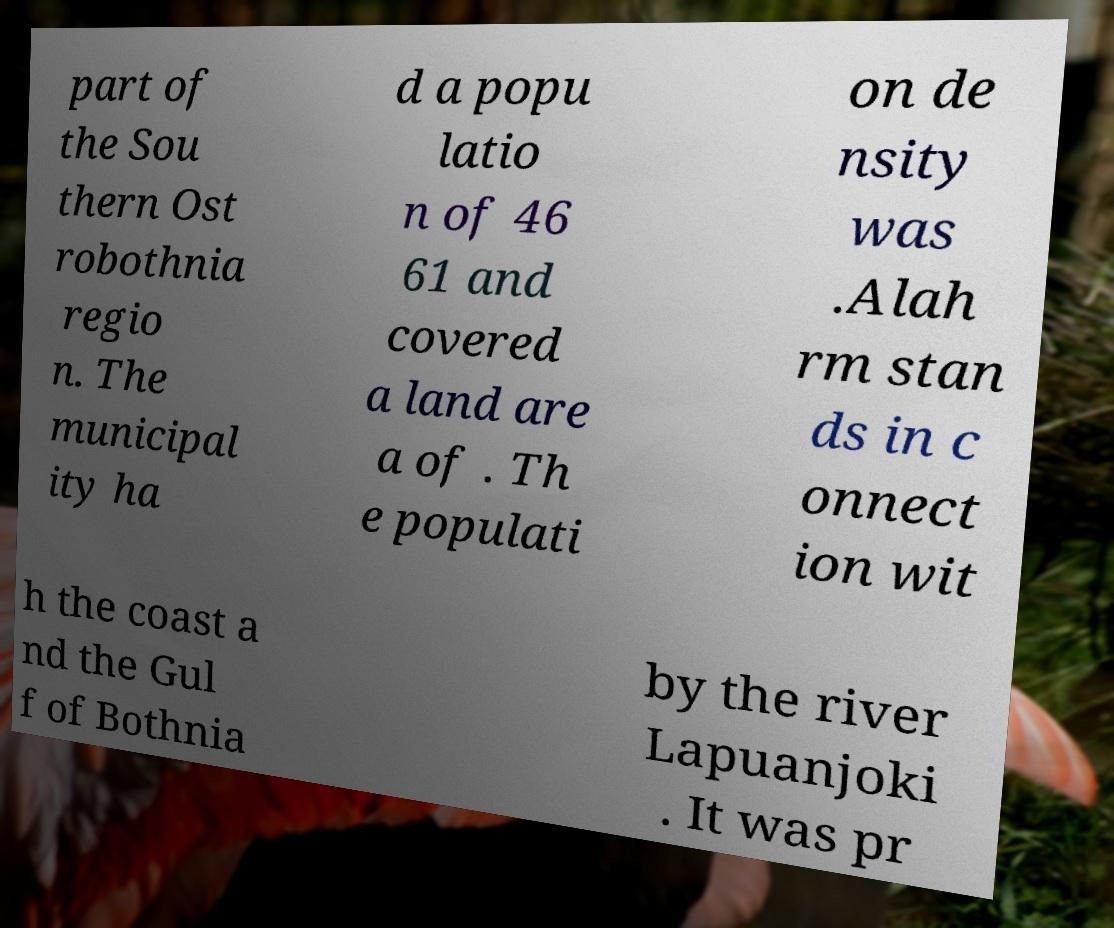I need the written content from this picture converted into text. Can you do that? part of the Sou thern Ost robothnia regio n. The municipal ity ha d a popu latio n of 46 61 and covered a land are a of . Th e populati on de nsity was .Alah rm stan ds in c onnect ion wit h the coast a nd the Gul f of Bothnia by the river Lapuanjoki . It was pr 